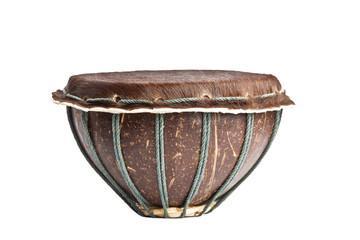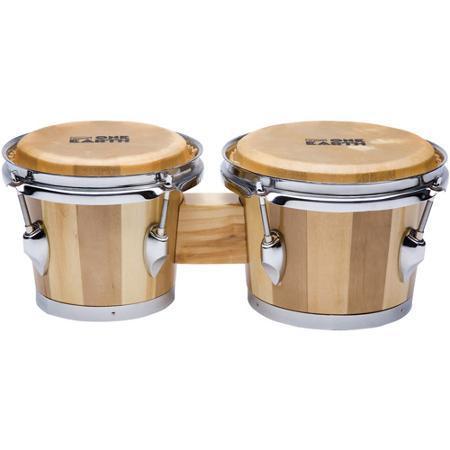The first image is the image on the left, the second image is the image on the right. For the images shown, is this caption "One image shows two basket-shaped drums connected side-by-side,and the other image shows a more slender chalice-shaped drum style, with a decorated base and rope netting around the sides." true? Answer yes or no. No. The first image is the image on the left, the second image is the image on the right. Considering the images on both sides, is "There are twice as many drums in the image on the right." valid? Answer yes or no. Yes. 